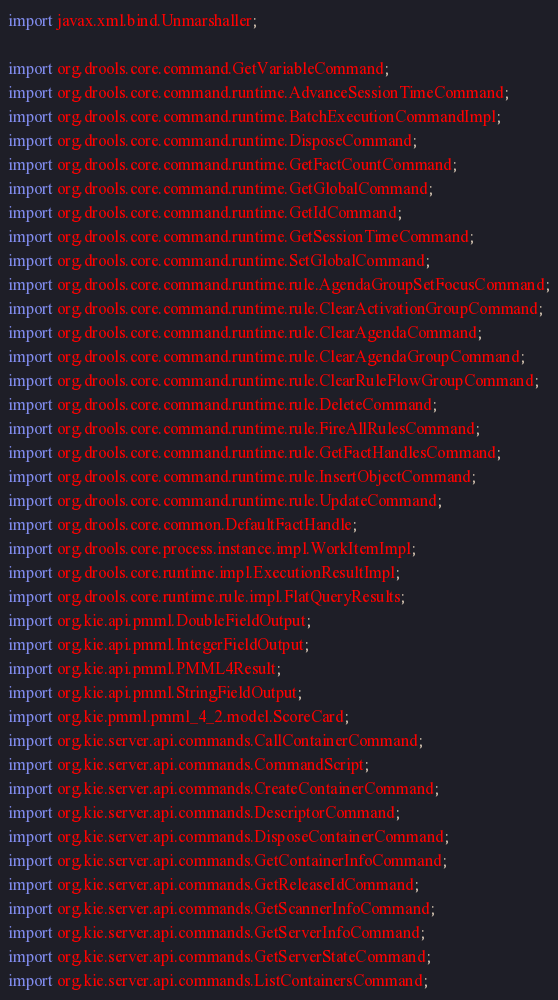<code> <loc_0><loc_0><loc_500><loc_500><_Java_>import javax.xml.bind.Unmarshaller;

import org.drools.core.command.GetVariableCommand;
import org.drools.core.command.runtime.AdvanceSessionTimeCommand;
import org.drools.core.command.runtime.BatchExecutionCommandImpl;
import org.drools.core.command.runtime.DisposeCommand;
import org.drools.core.command.runtime.GetFactCountCommand;
import org.drools.core.command.runtime.GetGlobalCommand;
import org.drools.core.command.runtime.GetIdCommand;
import org.drools.core.command.runtime.GetSessionTimeCommand;
import org.drools.core.command.runtime.SetGlobalCommand;
import org.drools.core.command.runtime.rule.AgendaGroupSetFocusCommand;
import org.drools.core.command.runtime.rule.ClearActivationGroupCommand;
import org.drools.core.command.runtime.rule.ClearAgendaCommand;
import org.drools.core.command.runtime.rule.ClearAgendaGroupCommand;
import org.drools.core.command.runtime.rule.ClearRuleFlowGroupCommand;
import org.drools.core.command.runtime.rule.DeleteCommand;
import org.drools.core.command.runtime.rule.FireAllRulesCommand;
import org.drools.core.command.runtime.rule.GetFactHandlesCommand;
import org.drools.core.command.runtime.rule.InsertObjectCommand;
import org.drools.core.command.runtime.rule.UpdateCommand;
import org.drools.core.common.DefaultFactHandle;
import org.drools.core.process.instance.impl.WorkItemImpl;
import org.drools.core.runtime.impl.ExecutionResultImpl;
import org.drools.core.runtime.rule.impl.FlatQueryResults;
import org.kie.api.pmml.DoubleFieldOutput;
import org.kie.api.pmml.IntegerFieldOutput;
import org.kie.api.pmml.PMML4Result;
import org.kie.api.pmml.StringFieldOutput;
import org.kie.pmml.pmml_4_2.model.ScoreCard;
import org.kie.server.api.commands.CallContainerCommand;
import org.kie.server.api.commands.CommandScript;
import org.kie.server.api.commands.CreateContainerCommand;
import org.kie.server.api.commands.DescriptorCommand;
import org.kie.server.api.commands.DisposeContainerCommand;
import org.kie.server.api.commands.GetContainerInfoCommand;
import org.kie.server.api.commands.GetReleaseIdCommand;
import org.kie.server.api.commands.GetScannerInfoCommand;
import org.kie.server.api.commands.GetServerInfoCommand;
import org.kie.server.api.commands.GetServerStateCommand;
import org.kie.server.api.commands.ListContainersCommand;</code> 